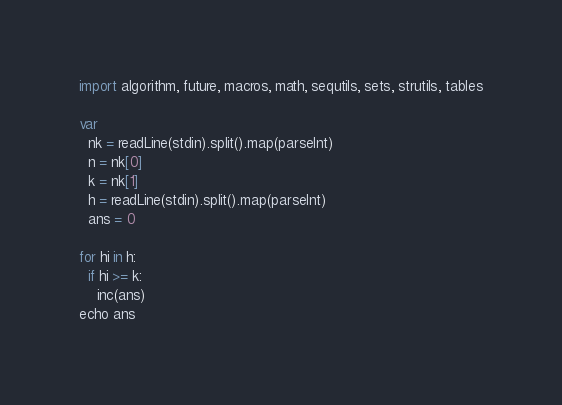Convert code to text. <code><loc_0><loc_0><loc_500><loc_500><_Nim_>import algorithm, future, macros, math, sequtils, sets, strutils, tables

var
  nk = readLine(stdin).split().map(parseInt)
  n = nk[0]
  k = nk[1]
  h = readLine(stdin).split().map(parseInt)
  ans = 0

for hi in h:
  if hi >= k:
    inc(ans)
echo ans</code> 